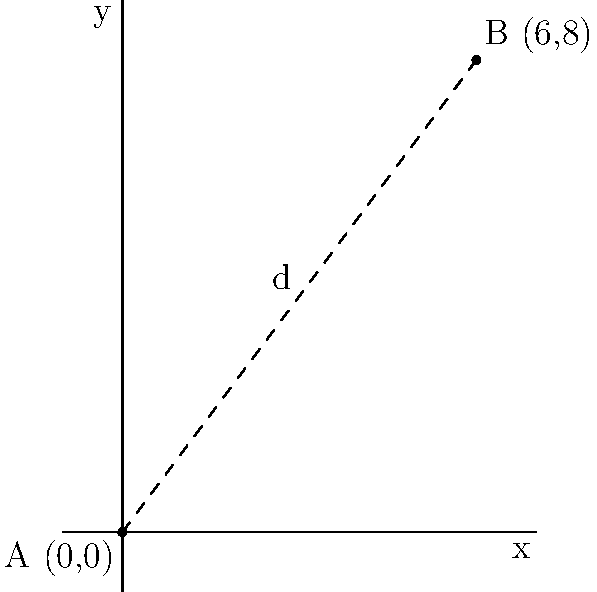Jacques Bourcart conducted significant research at two key locations represented by points A(0,0) and B(6,8) on a Cartesian plane, where each unit represents 10 kilometers. Calculate the straight-line distance $d$ between these two research sites. To find the distance between two points on a Cartesian plane, we can use the distance formula:

$$d = \sqrt{(x_2 - x_1)^2 + (y_2 - y_1)^2}$$

Where $(x_1, y_1)$ are the coordinates of point A and $(x_2, y_2)$ are the coordinates of point B.

Given:
- Point A: (0, 0)
- Point B: (6, 8)

Let's substitute these values into the formula:

$$d = \sqrt{(6 - 0)^2 + (8 - 0)^2}$$

Simplify:
$$d = \sqrt{6^2 + 8^2}$$
$$d = \sqrt{36 + 64}$$
$$d = \sqrt{100}$$
$$d = 10$$

Since each unit represents 10 kilometers, we multiply our result by 10:

$$10 \times 10 = 100\text{ km}$$

Therefore, the straight-line distance between Bourcart's two research locations is 100 kilometers.
Answer: 100 km 